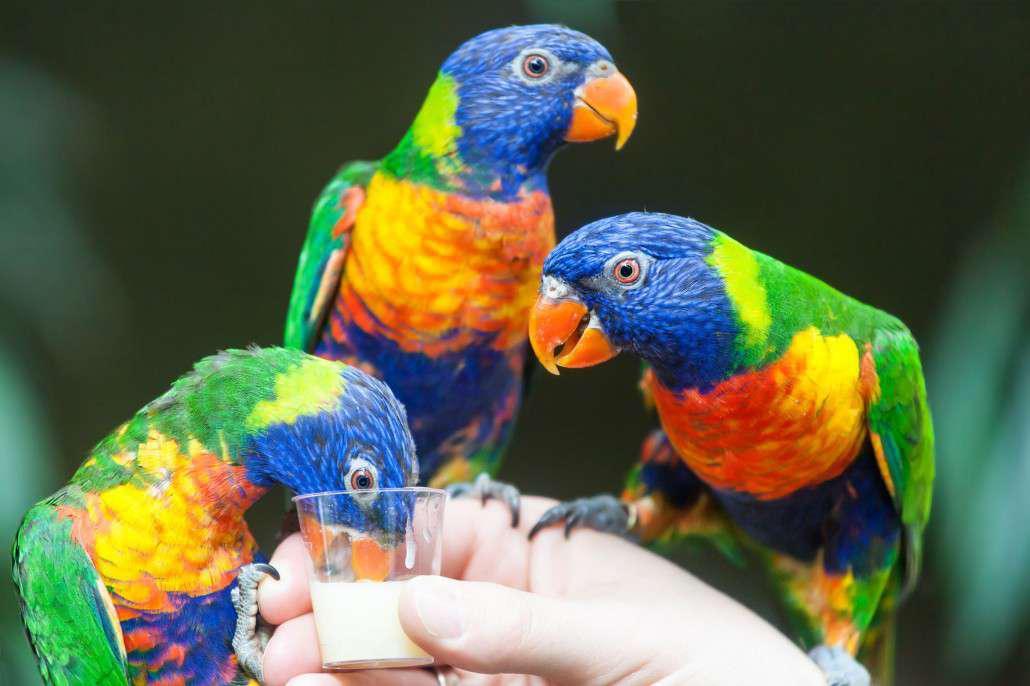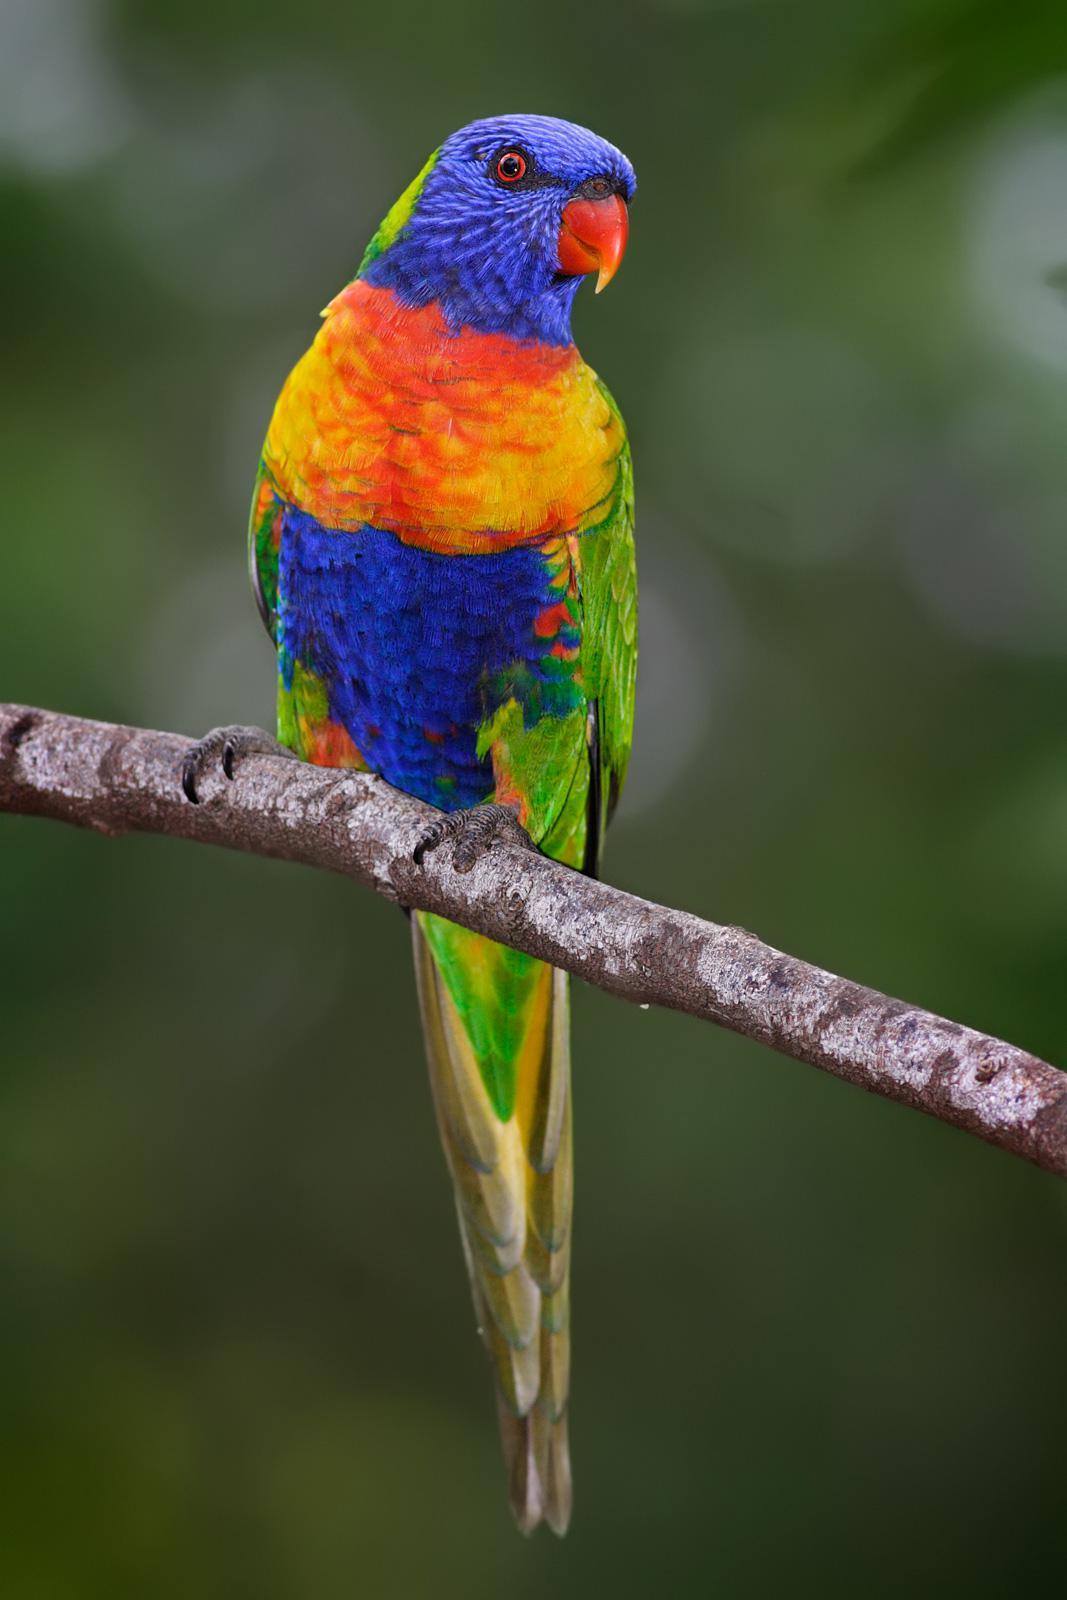The first image is the image on the left, the second image is the image on the right. Analyze the images presented: Is the assertion "An image shows exactly one parrot perched upright on a real tree branch." valid? Answer yes or no. Yes. The first image is the image on the left, the second image is the image on the right. Examine the images to the left and right. Is the description "Two birds are perched together in at least one of the images." accurate? Answer yes or no. No. 